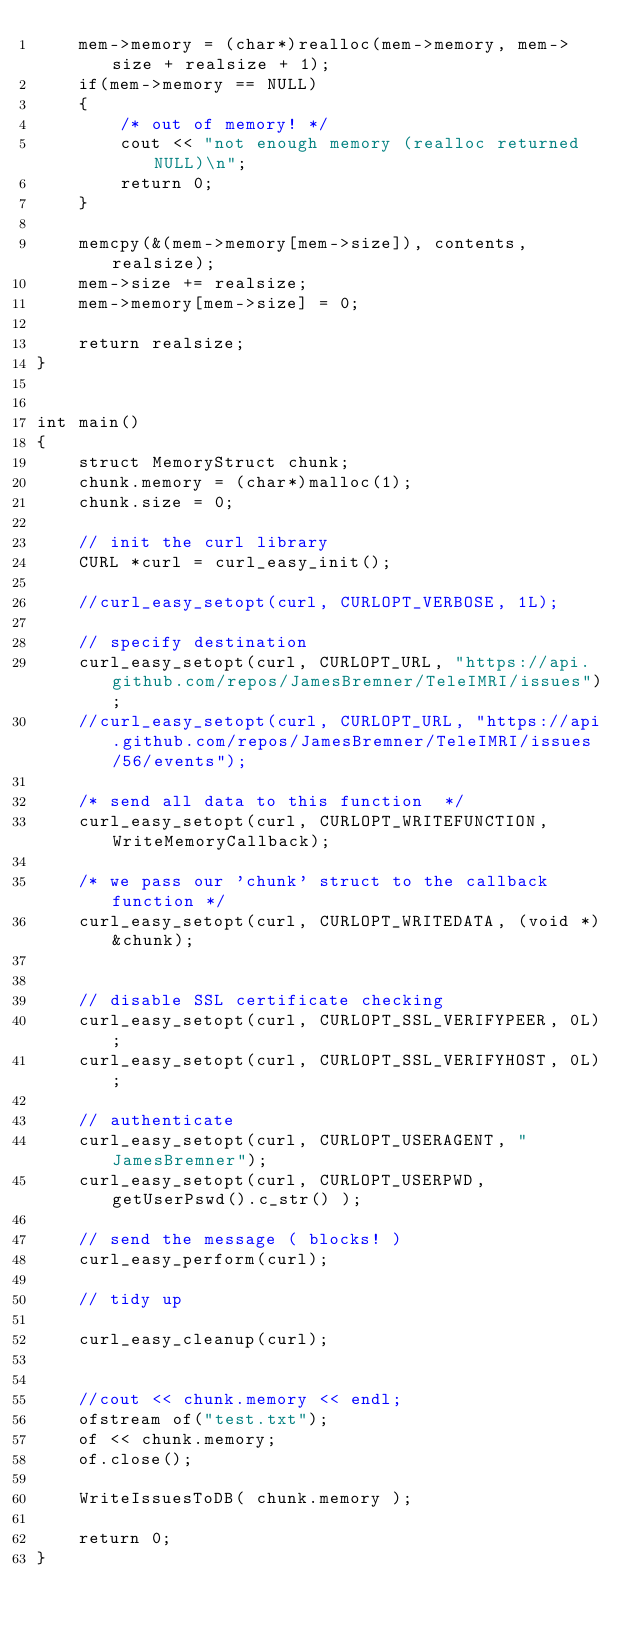<code> <loc_0><loc_0><loc_500><loc_500><_C++_>    mem->memory = (char*)realloc(mem->memory, mem->size + realsize + 1);
    if(mem->memory == NULL)
    {
        /* out of memory! */
        cout << "not enough memory (realloc returned NULL)\n";
        return 0;
    }

    memcpy(&(mem->memory[mem->size]), contents, realsize);
    mem->size += realsize;
    mem->memory[mem->size] = 0;

    return realsize;
}


int main()
{
    struct MemoryStruct chunk;
    chunk.memory = (char*)malloc(1);
    chunk.size = 0;

    // init the curl library
    CURL *curl = curl_easy_init();

    //curl_easy_setopt(curl, CURLOPT_VERBOSE, 1L);

    // specify destination
    curl_easy_setopt(curl, CURLOPT_URL, "https://api.github.com/repos/JamesBremner/TeleIMRI/issues");
    //curl_easy_setopt(curl, CURLOPT_URL, "https://api.github.com/repos/JamesBremner/TeleIMRI/issues/56/events");

    /* send all data to this function  */
    curl_easy_setopt(curl, CURLOPT_WRITEFUNCTION, WriteMemoryCallback);

    /* we pass our 'chunk' struct to the callback function */
    curl_easy_setopt(curl, CURLOPT_WRITEDATA, (void *)&chunk);


    // disable SSL certificate checking
    curl_easy_setopt(curl, CURLOPT_SSL_VERIFYPEER, 0L);
    curl_easy_setopt(curl, CURLOPT_SSL_VERIFYHOST, 0L);

    // authenticate
    curl_easy_setopt(curl, CURLOPT_USERAGENT, "JamesBremner");
    curl_easy_setopt(curl, CURLOPT_USERPWD, getUserPswd().c_str() );

    // send the message ( blocks! )
    curl_easy_perform(curl);

    // tidy up

    curl_easy_cleanup(curl);


    //cout << chunk.memory << endl;
    ofstream of("test.txt");
    of << chunk.memory;
    of.close();

    WriteIssuesToDB( chunk.memory );

    return 0;
}
</code> 